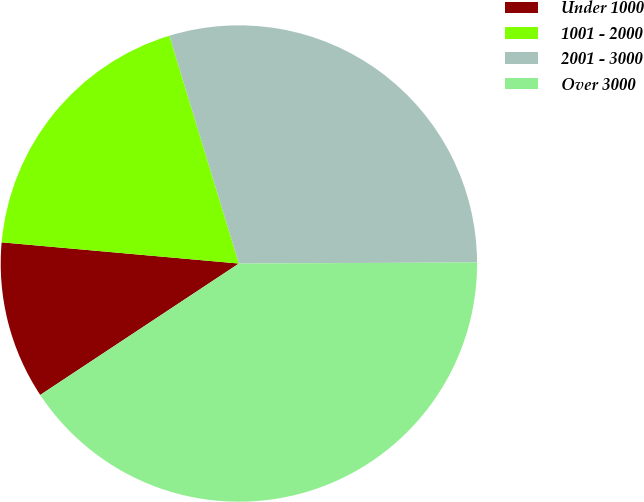<chart> <loc_0><loc_0><loc_500><loc_500><pie_chart><fcel>Under 1000<fcel>1001 - 2000<fcel>2001 - 3000<fcel>Over 3000<nl><fcel>10.72%<fcel>18.87%<fcel>29.64%<fcel>40.77%<nl></chart> 